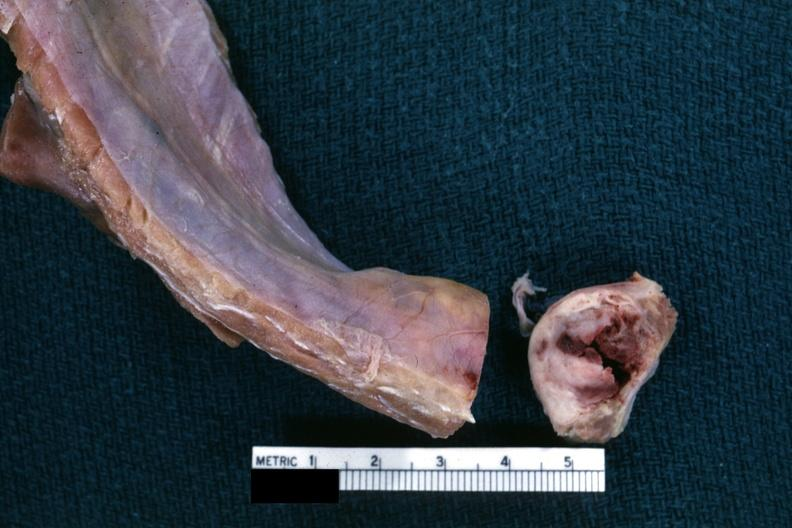how is obvious nodular rib lesion cross sectioned to show neoplasm with central hemorrhage?
Answer the question using a single word or phrase. White 